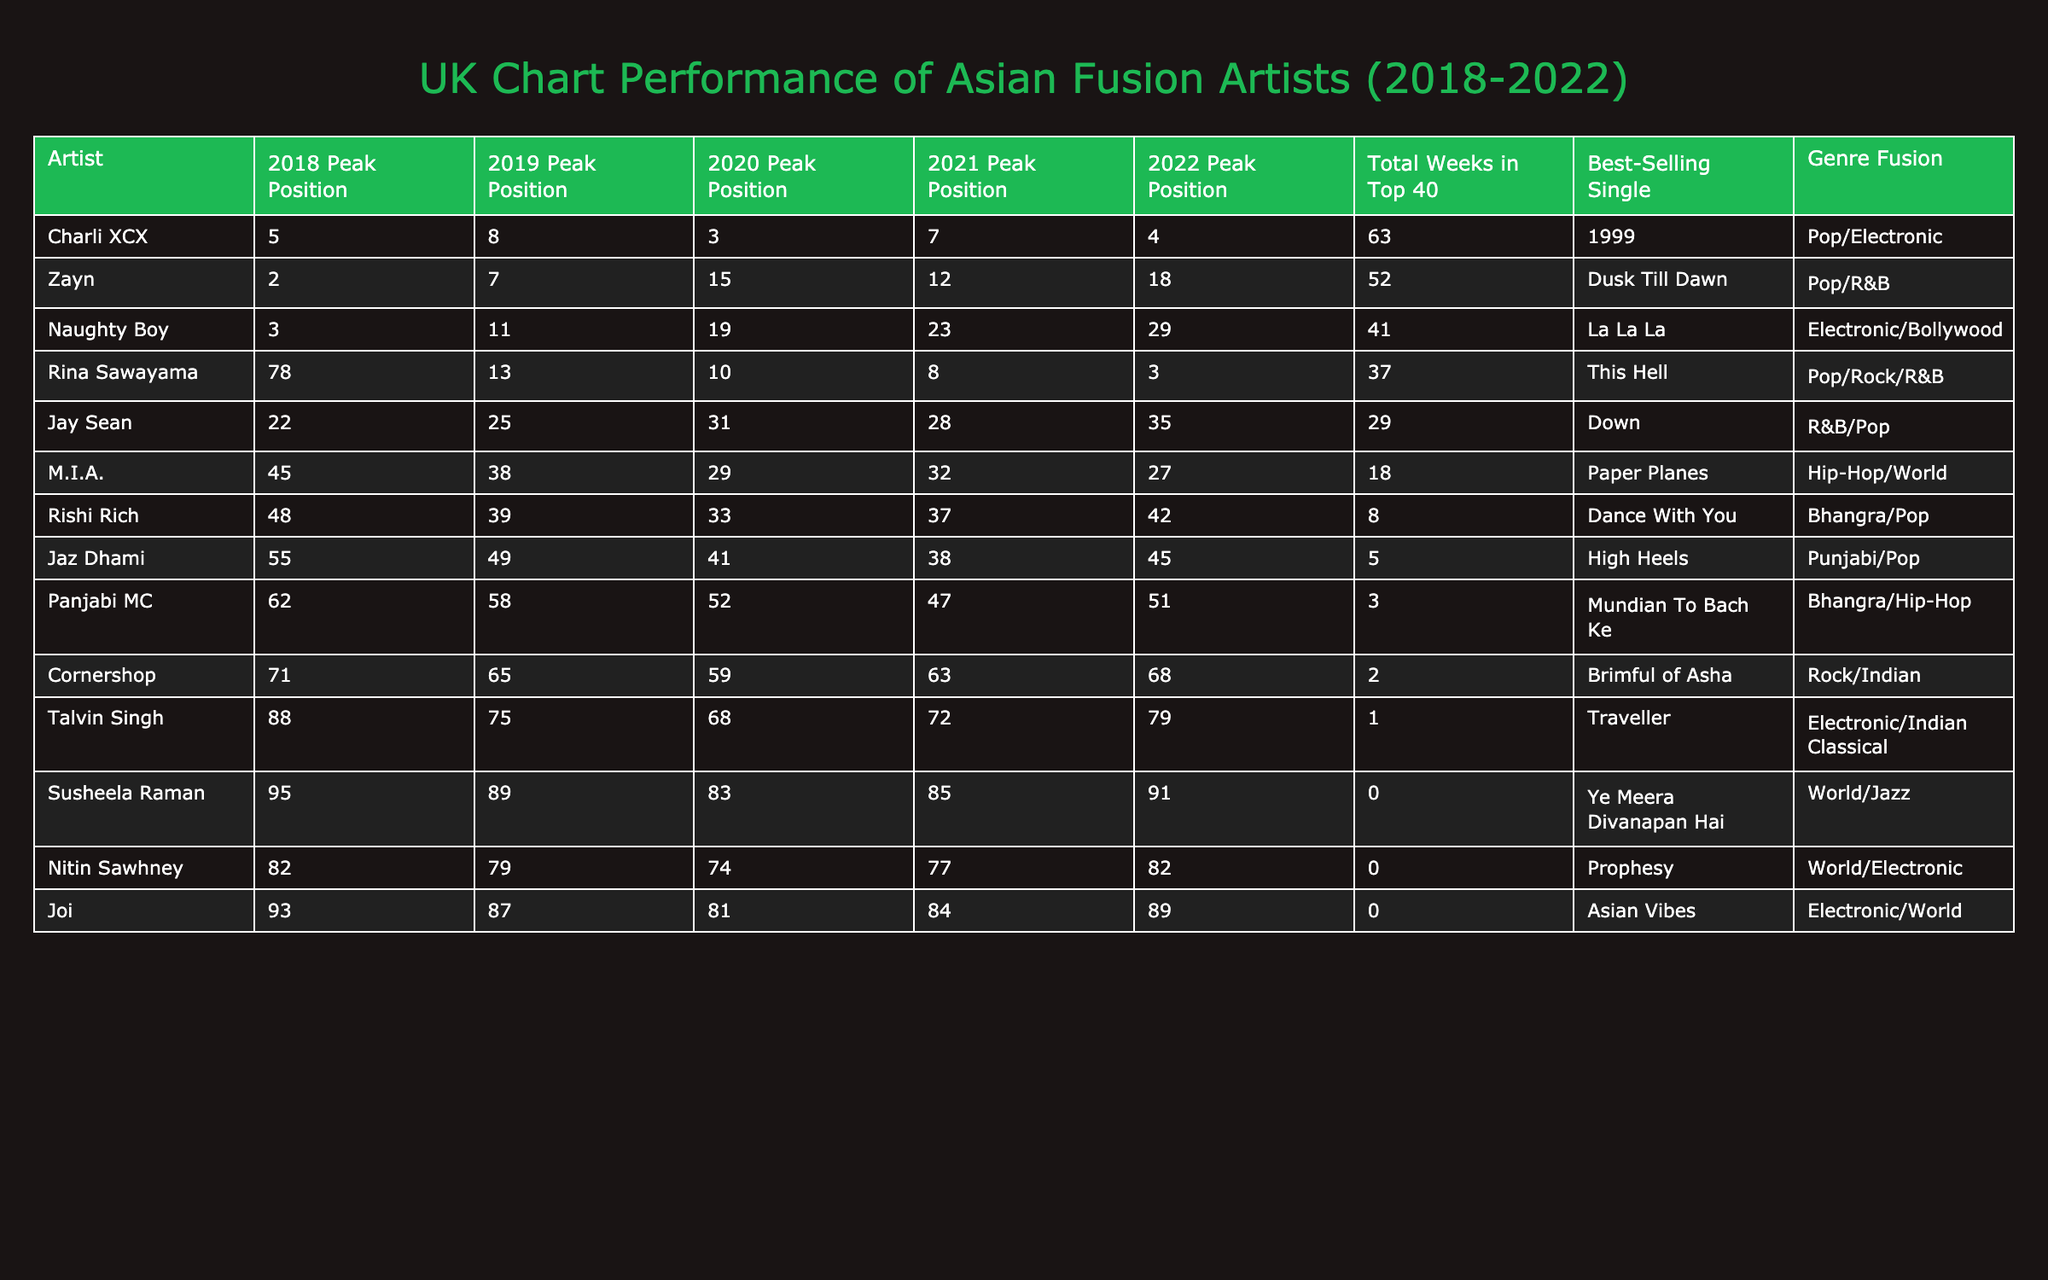What is the highest peak position of Zayn in the UK charts? Looking at the table, Zayn reached his highest peak position at number 2 in 2018.
Answer: 2 Which artist spent the most weeks in the Top 40? Scanning the table, Charli XCX spent the most weeks in the Top 40 with a total of 63 weeks.
Answer: 63 Did M.I.A. have a peak position in the Top 10 during the last 5 years? Checking the Peak Position column for M.I.A., the highest ranking she achieved was number 29, so she did not reach the Top 10.
Answer: No What is the average peak position of Jay Sean over the years? To find the average, add up Jay Sean's peak positions (22 + 25 + 31 + 28 + 35) = 141, and then divide by 5, giving 141/5 = 28.2.
Answer: 28.2 How many artists had a peak position in 2022 that was below 10? By reviewing the 2022 Peak Position column, only Rina Sawayama (3), and Zayn (18) had positions below 10, as only Rina's is below 10.
Answer: 1 Which genre fusion does Talvin Singh represent and what was his highest peak position? From the table, Talvin Singh is categorized under Electronic/Indian Classical, and his highest peak position was 68 in 2020.
Answer: Electronic/Indian Classical, 68 What percentage of artists peaked in the Top 20 at least once between 2018 and 2022? There are 15 artists; Zayn, Naughty Boy, Charli XCX, and Jay Sean reached the Top 20. That is 4 out of 15, which is (4/15) * 100 = 26.67%.
Answer: 26.67% Which artist had the best-selling single and what was it? In the table, Zayn is noted to have the best-selling single, "Dusk Till Dawn."
Answer: Zayn, "Dusk Till Dawn" How many positions did Panjabi MC improve from his peak position in 2018 to 2022? Panjabi MC peaked at 62 in 2018 and 51 in 2022; he improved by 11 positions (62 - 51 = 11).
Answer: 11 Which artist has the least total weeks in the Top 40 and what is that number? Looking at the Total Weeks in Top 40, Susheela Raman has the least with 0 weeks in the chart.
Answer: 0 